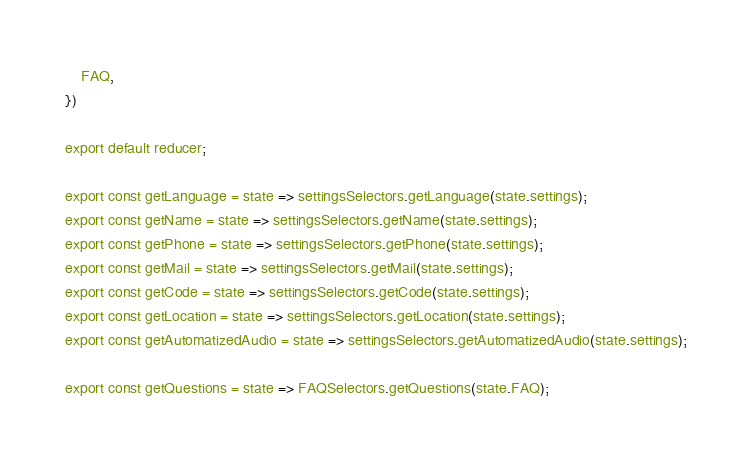Convert code to text. <code><loc_0><loc_0><loc_500><loc_500><_JavaScript_>    FAQ,
})

export default reducer;

export const getLanguage = state => settingsSelectors.getLanguage(state.settings);
export const getName = state => settingsSelectors.getName(state.settings);
export const getPhone = state => settingsSelectors.getPhone(state.settings);
export const getMail = state => settingsSelectors.getMail(state.settings);
export const getCode = state => settingsSelectors.getCode(state.settings);
export const getLocation = state => settingsSelectors.getLocation(state.settings);
export const getAutomatizedAudio = state => settingsSelectors.getAutomatizedAudio(state.settings);

export const getQuestions = state => FAQSelectors.getQuestions(state.FAQ);</code> 